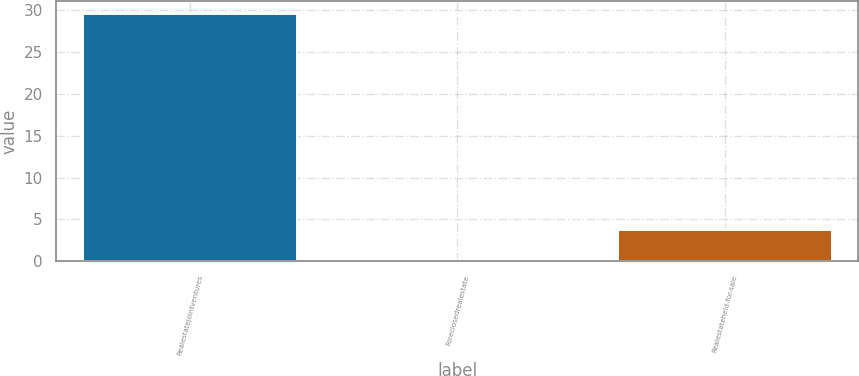<chart> <loc_0><loc_0><loc_500><loc_500><bar_chart><fcel>Realestatejointventures<fcel>Foreclosedrealestate<fcel>Realestateheld-for-sale<nl><fcel>29.6<fcel>0.1<fcel>3.7<nl></chart> 